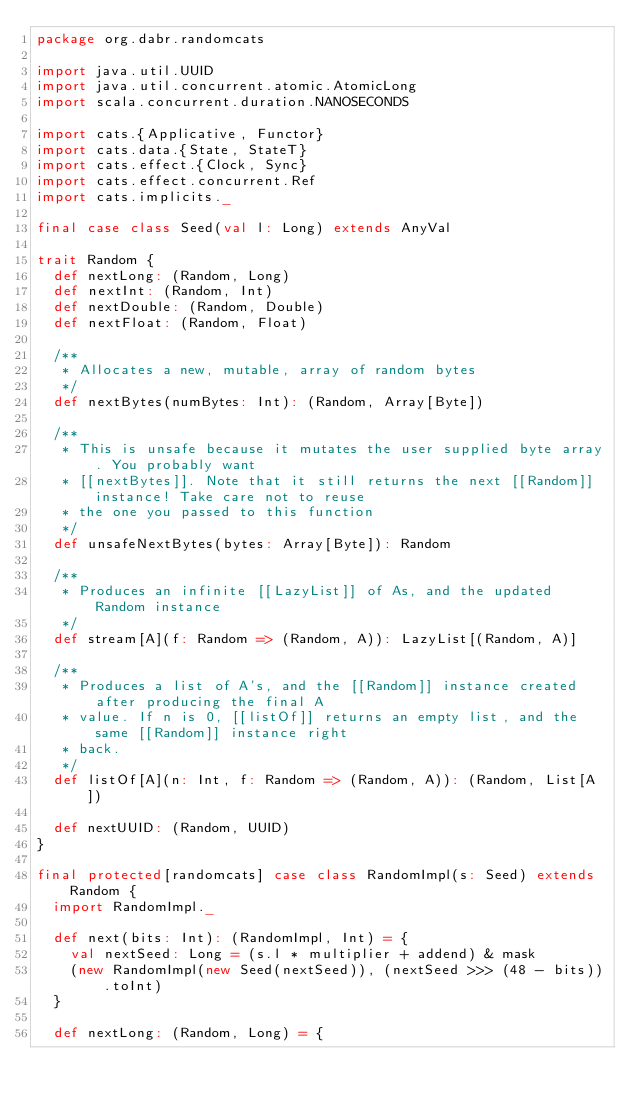<code> <loc_0><loc_0><loc_500><loc_500><_Scala_>package org.dabr.randomcats

import java.util.UUID
import java.util.concurrent.atomic.AtomicLong
import scala.concurrent.duration.NANOSECONDS

import cats.{Applicative, Functor}
import cats.data.{State, StateT}
import cats.effect.{Clock, Sync}
import cats.effect.concurrent.Ref
import cats.implicits._

final case class Seed(val l: Long) extends AnyVal

trait Random {
  def nextLong: (Random, Long)
  def nextInt: (Random, Int)
  def nextDouble: (Random, Double)
  def nextFloat: (Random, Float)

  /**
   * Allocates a new, mutable, array of random bytes
   */
  def nextBytes(numBytes: Int): (Random, Array[Byte])

  /**
   * This is unsafe because it mutates the user supplied byte array. You probably want
   * [[nextBytes]]. Note that it still returns the next [[Random]] instance! Take care not to reuse
   * the one you passed to this function
   */
  def unsafeNextBytes(bytes: Array[Byte]): Random

  /**
   * Produces an infinite [[LazyList]] of As, and the updated Random instance
   */
  def stream[A](f: Random => (Random, A)): LazyList[(Random, A)]

  /**
   * Produces a list of A's, and the [[Random]] instance created after producing the final A
   * value. If n is 0, [[listOf]] returns an empty list, and the same [[Random]] instance right
   * back.
   */
  def listOf[A](n: Int, f: Random => (Random, A)): (Random, List[A])

  def nextUUID: (Random, UUID)
}

final protected[randomcats] case class RandomImpl(s: Seed) extends Random {
  import RandomImpl._

  def next(bits: Int): (RandomImpl, Int) = {
    val nextSeed: Long = (s.l * multiplier + addend) & mask
    (new RandomImpl(new Seed(nextSeed)), (nextSeed >>> (48 - bits)).toInt)
  }

  def nextLong: (Random, Long) = {</code> 